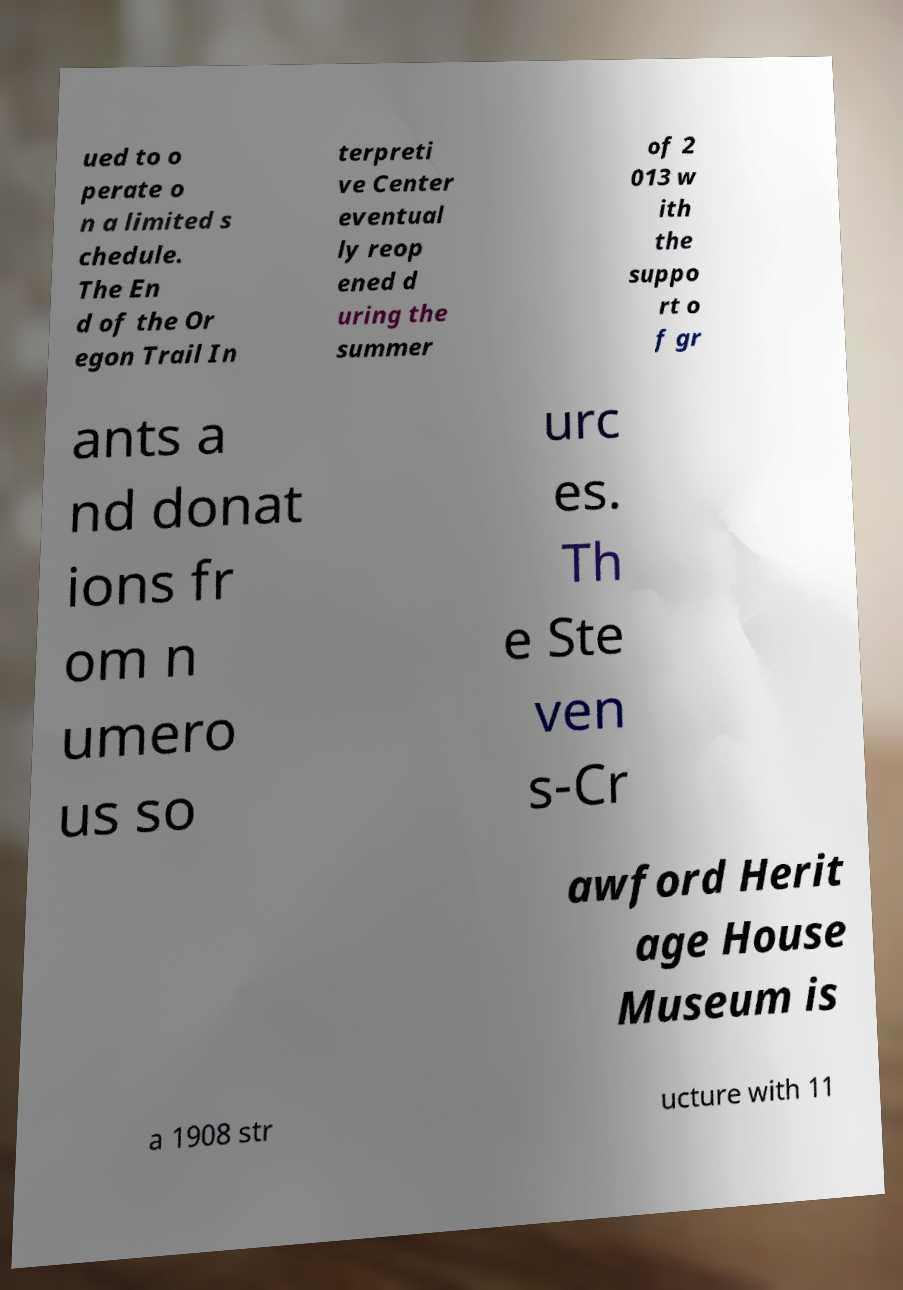I need the written content from this picture converted into text. Can you do that? ued to o perate o n a limited s chedule. The En d of the Or egon Trail In terpreti ve Center eventual ly reop ened d uring the summer of 2 013 w ith the suppo rt o f gr ants a nd donat ions fr om n umero us so urc es. Th e Ste ven s-Cr awford Herit age House Museum is a 1908 str ucture with 11 